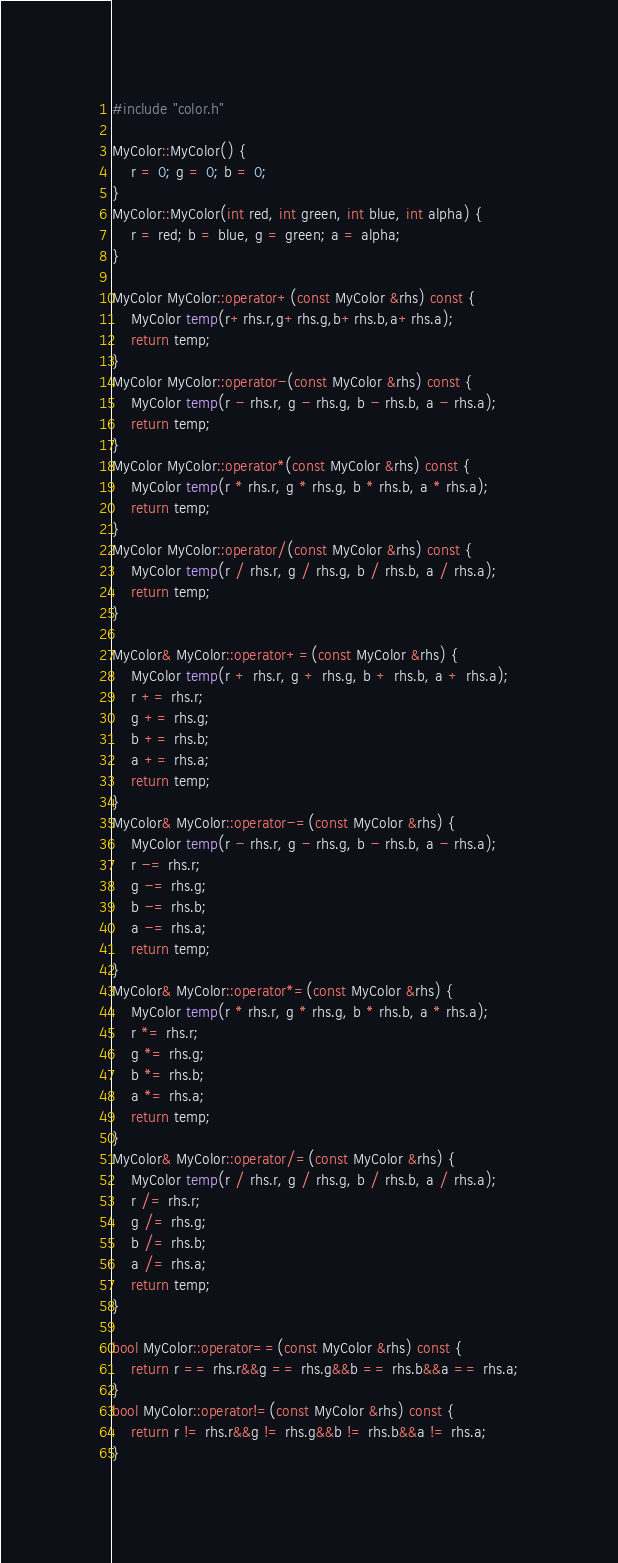<code> <loc_0><loc_0><loc_500><loc_500><_C++_>#include "color.h"

MyColor::MyColor() {
	r = 0; g = 0; b = 0;
}
MyColor::MyColor(int red, int green, int blue, int alpha) {
	r = red; b = blue, g = green; a = alpha;
}

MyColor MyColor::operator+(const MyColor &rhs) const {
	MyColor temp(r+rhs.r,g+rhs.g,b+rhs.b,a+rhs.a);
	return temp;
}
MyColor MyColor::operator-(const MyColor &rhs) const {
	MyColor temp(r - rhs.r, g - rhs.g, b - rhs.b, a - rhs.a);
	return temp;
}
MyColor MyColor::operator*(const MyColor &rhs) const {
	MyColor temp(r * rhs.r, g * rhs.g, b * rhs.b, a * rhs.a);
	return temp;
}
MyColor MyColor::operator/(const MyColor &rhs) const {
	MyColor temp(r / rhs.r, g / rhs.g, b / rhs.b, a / rhs.a);
	return temp;
}

MyColor& MyColor::operator+=(const MyColor &rhs) {
	MyColor temp(r + rhs.r, g + rhs.g, b + rhs.b, a + rhs.a);
	r += rhs.r;
	g += rhs.g;
	b += rhs.b;
	a += rhs.a;
	return temp;
}
MyColor& MyColor::operator-=(const MyColor &rhs) {
	MyColor temp(r - rhs.r, g - rhs.g, b - rhs.b, a - rhs.a);
	r -= rhs.r;
	g -= rhs.g;
	b -= rhs.b;
	a -= rhs.a;
	return temp;
}
MyColor& MyColor::operator*=(const MyColor &rhs) {
	MyColor temp(r * rhs.r, g * rhs.g, b * rhs.b, a * rhs.a);
	r *= rhs.r;
	g *= rhs.g;
	b *= rhs.b;
	a *= rhs.a;
	return temp;
}
MyColor& MyColor::operator/=(const MyColor &rhs) {
	MyColor temp(r / rhs.r, g / rhs.g, b / rhs.b, a / rhs.a);
	r /= rhs.r;
	g /= rhs.g;
	b /= rhs.b;
	a /= rhs.a;
	return temp;
}

bool MyColor::operator==(const MyColor &rhs) const {
	return r == rhs.r&&g == rhs.g&&b == rhs.b&&a == rhs.a;
}
bool MyColor::operator!=(const MyColor &rhs) const {
	return r != rhs.r&&g != rhs.g&&b != rhs.b&&a != rhs.a;
}</code> 